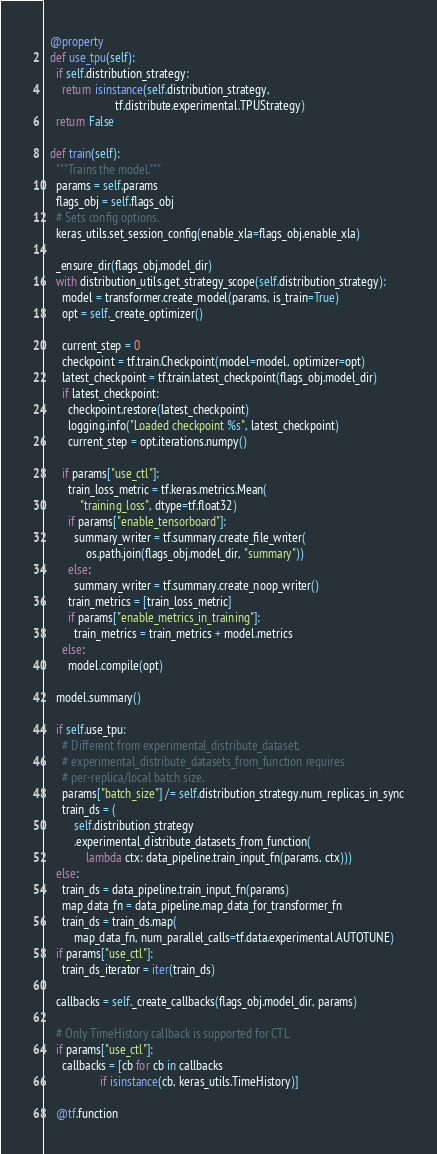Convert code to text. <code><loc_0><loc_0><loc_500><loc_500><_Python_>
  @property
  def use_tpu(self):
    if self.distribution_strategy:
      return isinstance(self.distribution_strategy,
                        tf.distribute.experimental.TPUStrategy)
    return False

  def train(self):
    """Trains the model."""
    params = self.params
    flags_obj = self.flags_obj
    # Sets config options.
    keras_utils.set_session_config(enable_xla=flags_obj.enable_xla)

    _ensure_dir(flags_obj.model_dir)
    with distribution_utils.get_strategy_scope(self.distribution_strategy):
      model = transformer.create_model(params, is_train=True)
      opt = self._create_optimizer()

      current_step = 0
      checkpoint = tf.train.Checkpoint(model=model, optimizer=opt)
      latest_checkpoint = tf.train.latest_checkpoint(flags_obj.model_dir)
      if latest_checkpoint:
        checkpoint.restore(latest_checkpoint)
        logging.info("Loaded checkpoint %s", latest_checkpoint)
        current_step = opt.iterations.numpy()

      if params["use_ctl"]:
        train_loss_metric = tf.keras.metrics.Mean(
            "training_loss", dtype=tf.float32)
        if params["enable_tensorboard"]:
          summary_writer = tf.summary.create_file_writer(
              os.path.join(flags_obj.model_dir, "summary"))
        else:
          summary_writer = tf.summary.create_noop_writer()
        train_metrics = [train_loss_metric]
        if params["enable_metrics_in_training"]:
          train_metrics = train_metrics + model.metrics
      else:
        model.compile(opt)

    model.summary()

    if self.use_tpu:
      # Different from experimental_distribute_dataset,
      # experimental_distribute_datasets_from_function requires
      # per-replica/local batch size.
      params["batch_size"] /= self.distribution_strategy.num_replicas_in_sync
      train_ds = (
          self.distribution_strategy
          .experimental_distribute_datasets_from_function(
              lambda ctx: data_pipeline.train_input_fn(params, ctx)))
    else:
      train_ds = data_pipeline.train_input_fn(params)
      map_data_fn = data_pipeline.map_data_for_transformer_fn
      train_ds = train_ds.map(
          map_data_fn, num_parallel_calls=tf.data.experimental.AUTOTUNE)
    if params["use_ctl"]:
      train_ds_iterator = iter(train_ds)

    callbacks = self._create_callbacks(flags_obj.model_dir, params)

    # Only TimeHistory callback is supported for CTL
    if params["use_ctl"]:
      callbacks = [cb for cb in callbacks
                   if isinstance(cb, keras_utils.TimeHistory)]

    @tf.function</code> 